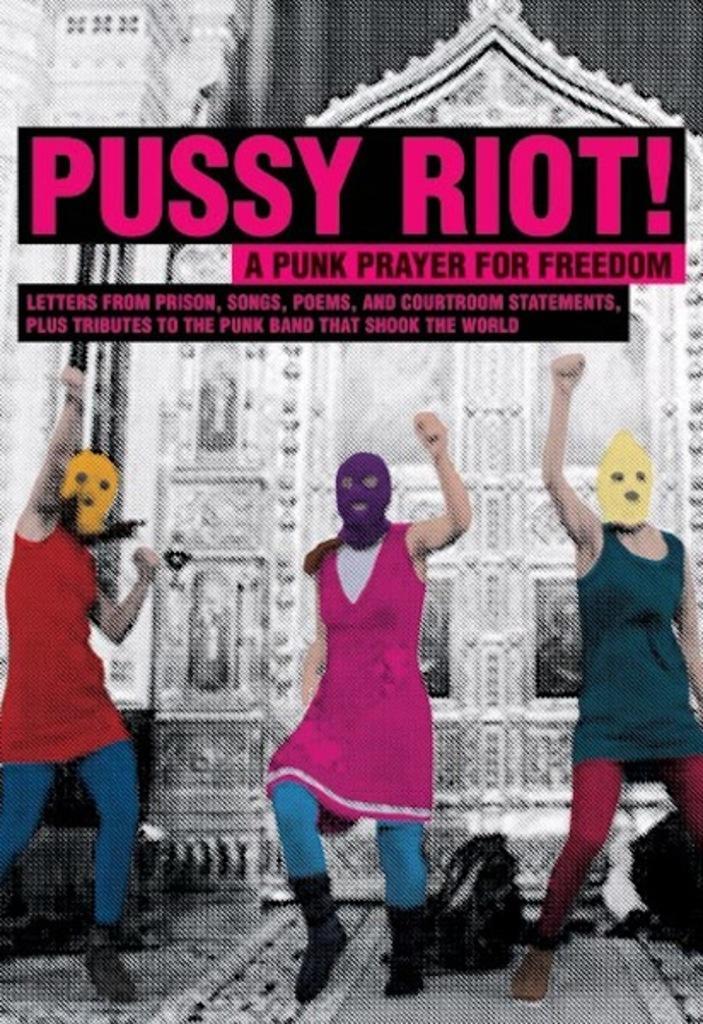Can you describe this image briefly? Here in this picture we can see poster, on which we can see three persons standing on the floor, wearing face masks on them and we can see bags present over there and behind them we can see building present and we can see some text written on it over there. 